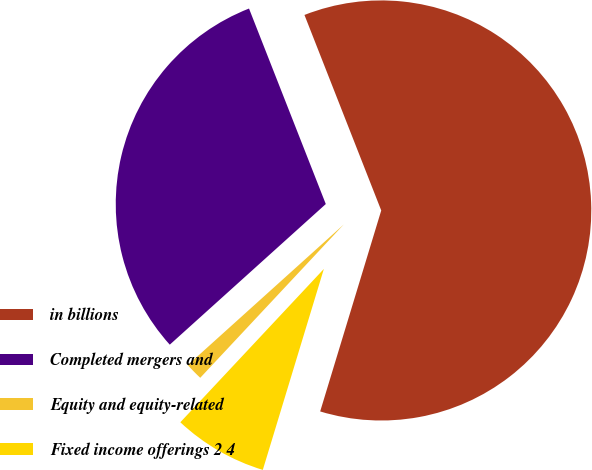Convert chart to OTSL. <chart><loc_0><loc_0><loc_500><loc_500><pie_chart><fcel>in billions<fcel>Completed mergers and<fcel>Equity and equity-related<fcel>Fixed income offerings 2 4<nl><fcel>60.65%<fcel>30.72%<fcel>1.35%<fcel>7.28%<nl></chart> 